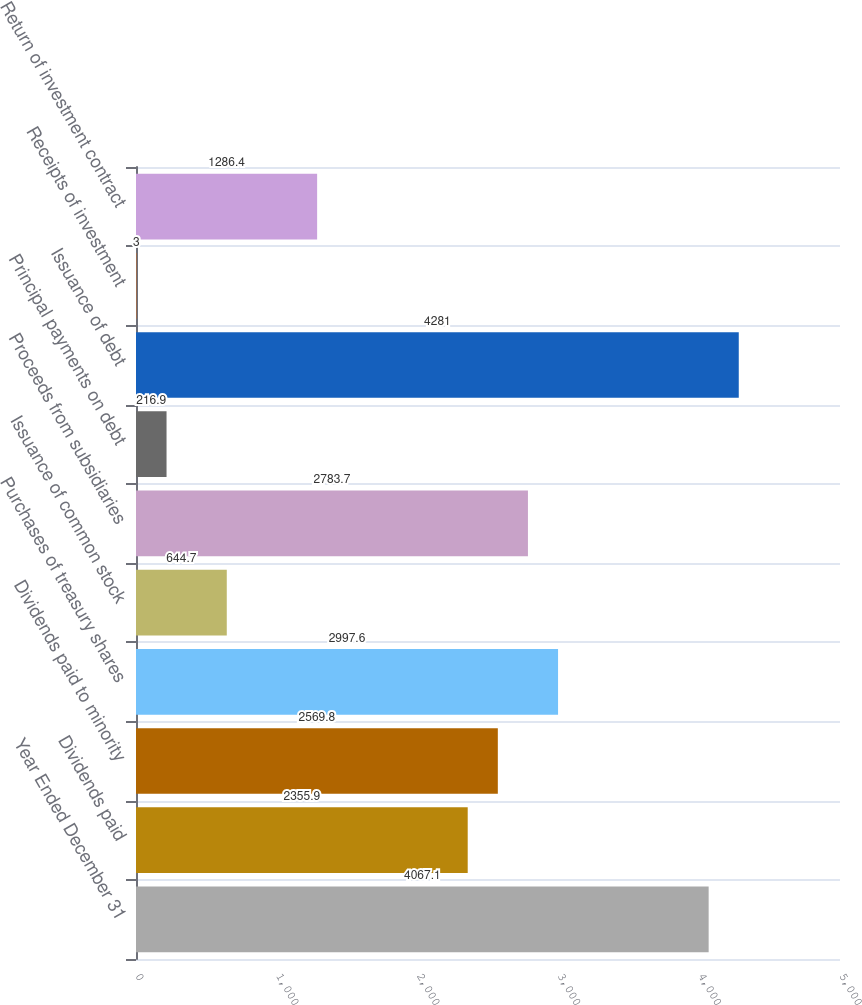<chart> <loc_0><loc_0><loc_500><loc_500><bar_chart><fcel>Year Ended December 31<fcel>Dividends paid<fcel>Dividends paid to minority<fcel>Purchases of treasury shares<fcel>Issuance of common stock<fcel>Proceeds from subsidiaries<fcel>Principal payments on debt<fcel>Issuance of debt<fcel>Receipts of investment<fcel>Return of investment contract<nl><fcel>4067.1<fcel>2355.9<fcel>2569.8<fcel>2997.6<fcel>644.7<fcel>2783.7<fcel>216.9<fcel>4281<fcel>3<fcel>1286.4<nl></chart> 